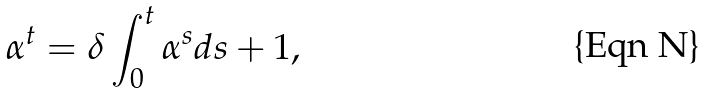Convert formula to latex. <formula><loc_0><loc_0><loc_500><loc_500>\alpha ^ { t } = \delta \int _ { 0 } ^ { t } \alpha ^ { s } d s + 1 ,</formula> 